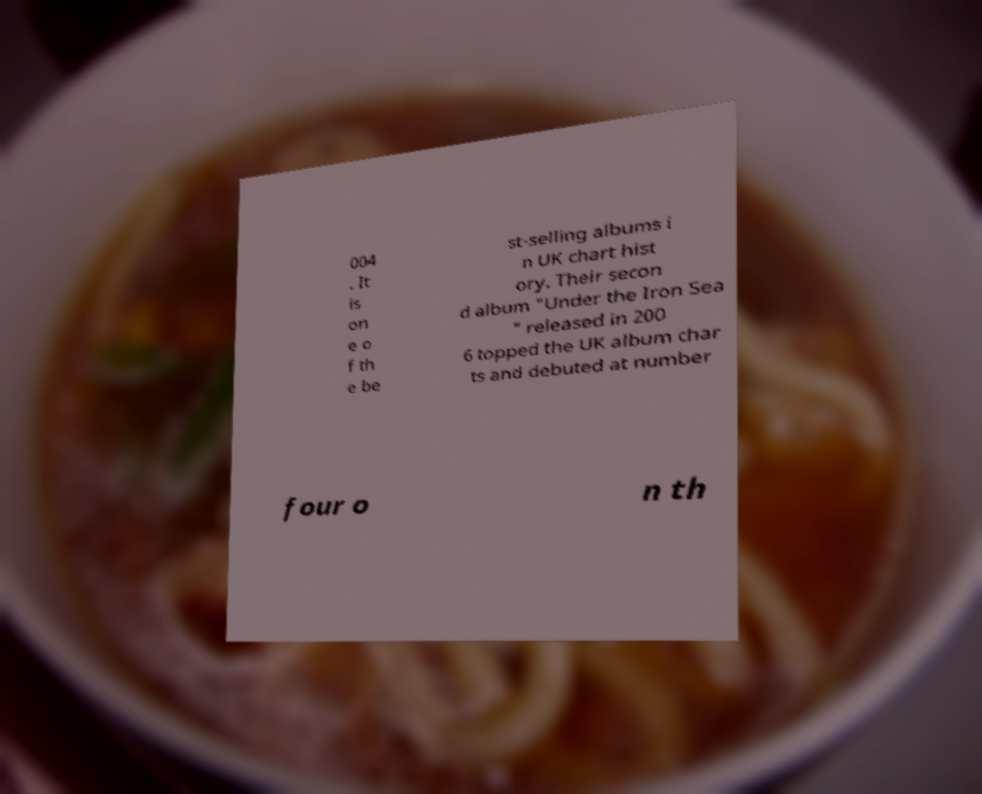There's text embedded in this image that I need extracted. Can you transcribe it verbatim? 004 . It is on e o f th e be st-selling albums i n UK chart hist ory. Their secon d album "Under the Iron Sea " released in 200 6 topped the UK album char ts and debuted at number four o n th 